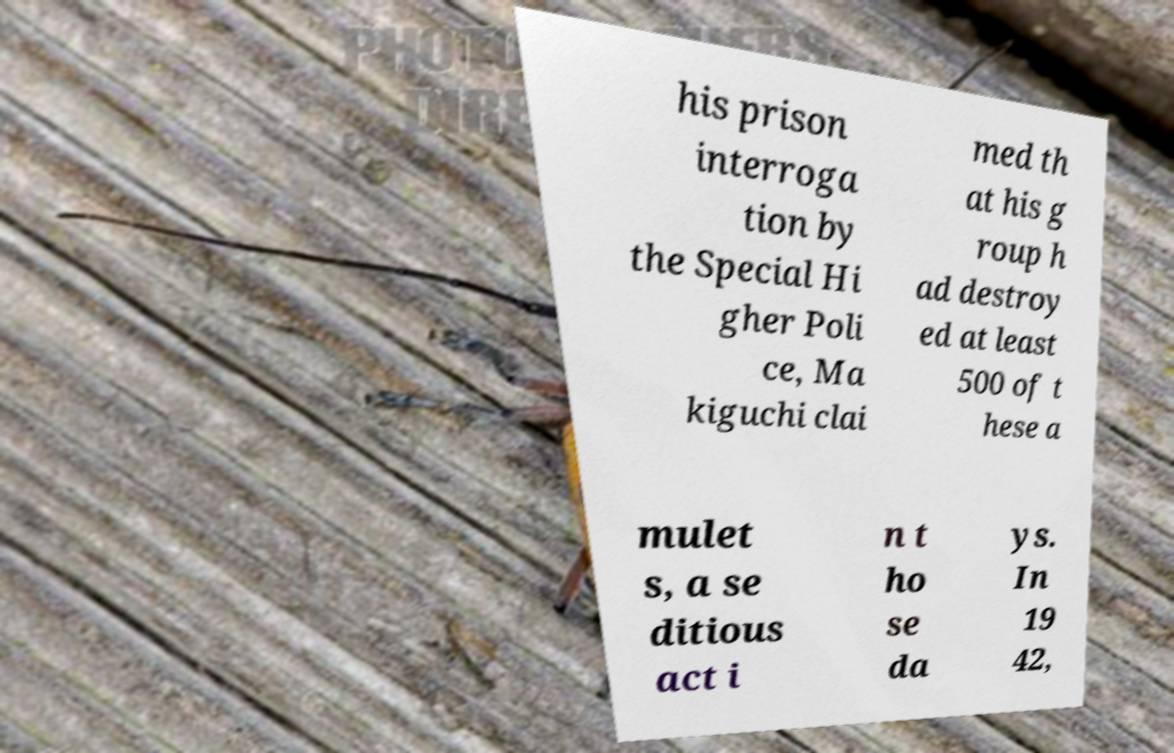There's text embedded in this image that I need extracted. Can you transcribe it verbatim? his prison interroga tion by the Special Hi gher Poli ce, Ma kiguchi clai med th at his g roup h ad destroy ed at least 500 of t hese a mulet s, a se ditious act i n t ho se da ys. In 19 42, 